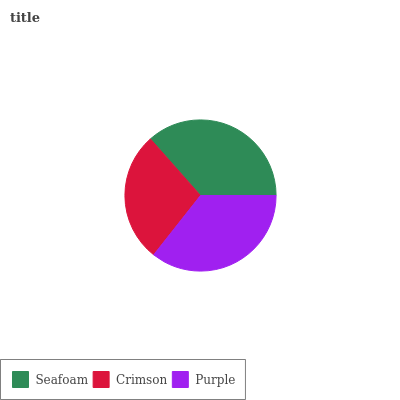Is Crimson the minimum?
Answer yes or no. Yes. Is Seafoam the maximum?
Answer yes or no. Yes. Is Purple the minimum?
Answer yes or no. No. Is Purple the maximum?
Answer yes or no. No. Is Purple greater than Crimson?
Answer yes or no. Yes. Is Crimson less than Purple?
Answer yes or no. Yes. Is Crimson greater than Purple?
Answer yes or no. No. Is Purple less than Crimson?
Answer yes or no. No. Is Purple the high median?
Answer yes or no. Yes. Is Purple the low median?
Answer yes or no. Yes. Is Crimson the high median?
Answer yes or no. No. Is Crimson the low median?
Answer yes or no. No. 